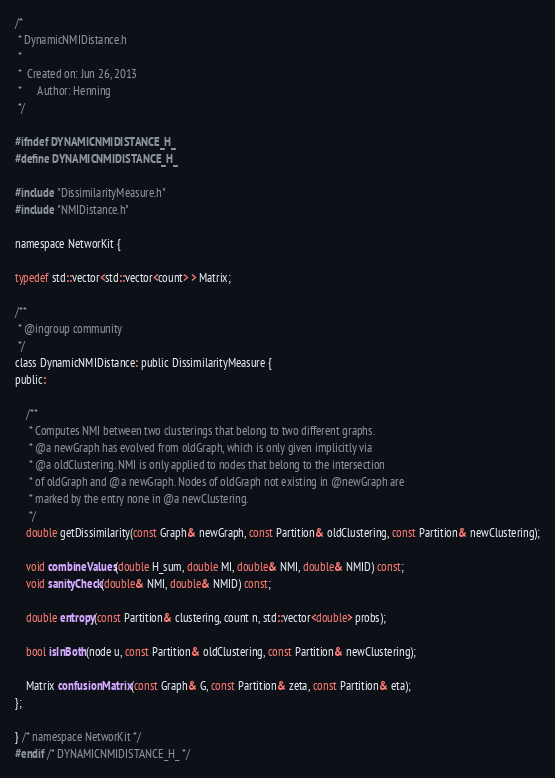Convert code to text. <code><loc_0><loc_0><loc_500><loc_500><_C_>/*
 * DynamicNMIDistance.h
 *
 *  Created on: Jun 26, 2013
 *      Author: Henning
 */

#ifndef DYNAMICNMIDISTANCE_H_
#define DYNAMICNMIDISTANCE_H_

#include "DissimilarityMeasure.h"
#include "NMIDistance.h"

namespace NetworKit {

typedef std::vector<std::vector<count> > Matrix;

/**
 * @ingroup community
 */
class DynamicNMIDistance: public DissimilarityMeasure {
public:

	/**
	 * Computes NMI between two clusterings that belong to two different graphs.
	 * @a newGraph has evolved from oldGraph, which is only given implicitly via
	 * @a oldClustering. NMI is only applied to nodes that belong to the intersection
	 * of oldGraph and @a newGraph. Nodes of oldGraph not existing in @newGraph are
	 * marked by the entry none in @a newClustering.
	 */
	double getDissimilarity(const Graph& newGraph, const Partition& oldClustering, const Partition& newClustering);

	void combineValues(double H_sum, double MI, double& NMI, double& NMID) const;
	void sanityCheck(double& NMI, double& NMID) const;

	double entropy(const Partition& clustering, count n, std::vector<double> probs);

	bool isInBoth(node u, const Partition& oldClustering, const Partition& newClustering);

	Matrix confusionMatrix(const Graph& G, const Partition& zeta, const Partition& eta);
};

} /* namespace NetworKit */
#endif /* DYNAMICNMIDISTANCE_H_ */
</code> 